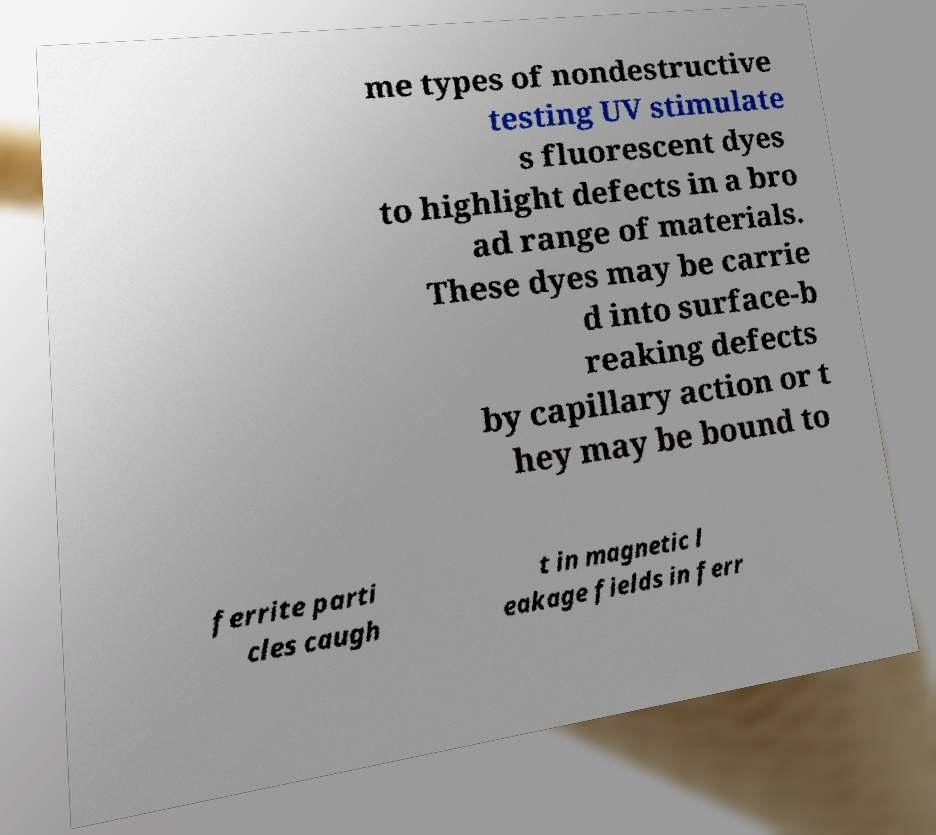Can you read and provide the text displayed in the image?This photo seems to have some interesting text. Can you extract and type it out for me? me types of nondestructive testing UV stimulate s fluorescent dyes to highlight defects in a bro ad range of materials. These dyes may be carrie d into surface-b reaking defects by capillary action or t hey may be bound to ferrite parti cles caugh t in magnetic l eakage fields in ferr 